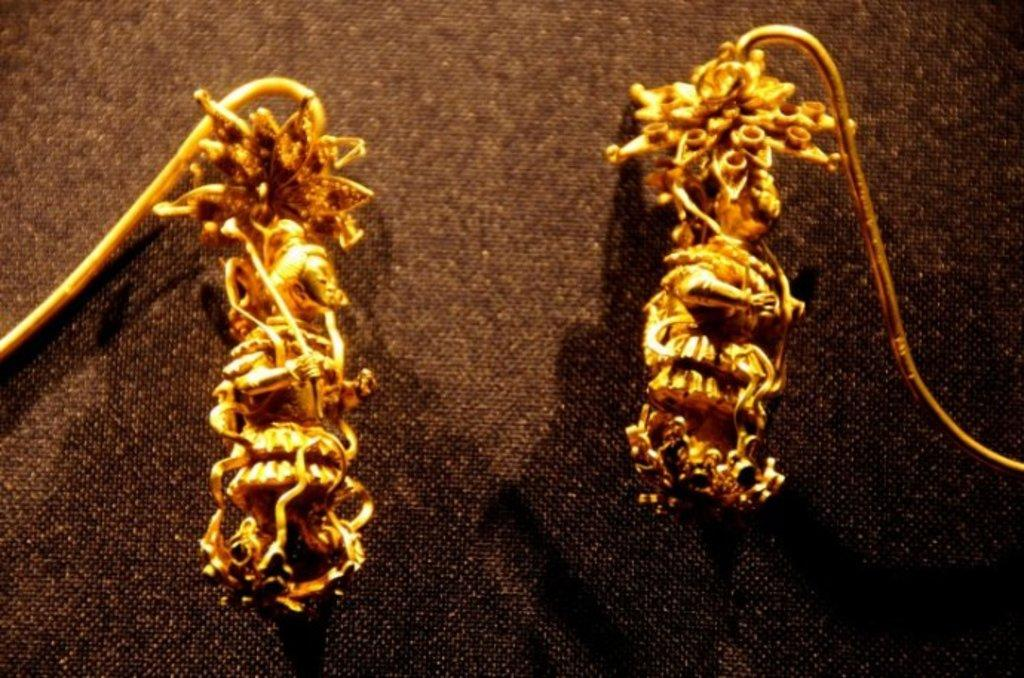What is the color of the mini sculptures in the image? The mini sculptures in the image are golden in color. What is the color of the object under the mini sculptures? The object under the mini sculptures is black in color. How many passengers are visible in the image? There are no passengers present in the image; it features golden color mini sculptures and a black object. What grade is the sculpture in the image? The image does not contain any sculptures, only mini sculptures, and there is no indication of a grade. 